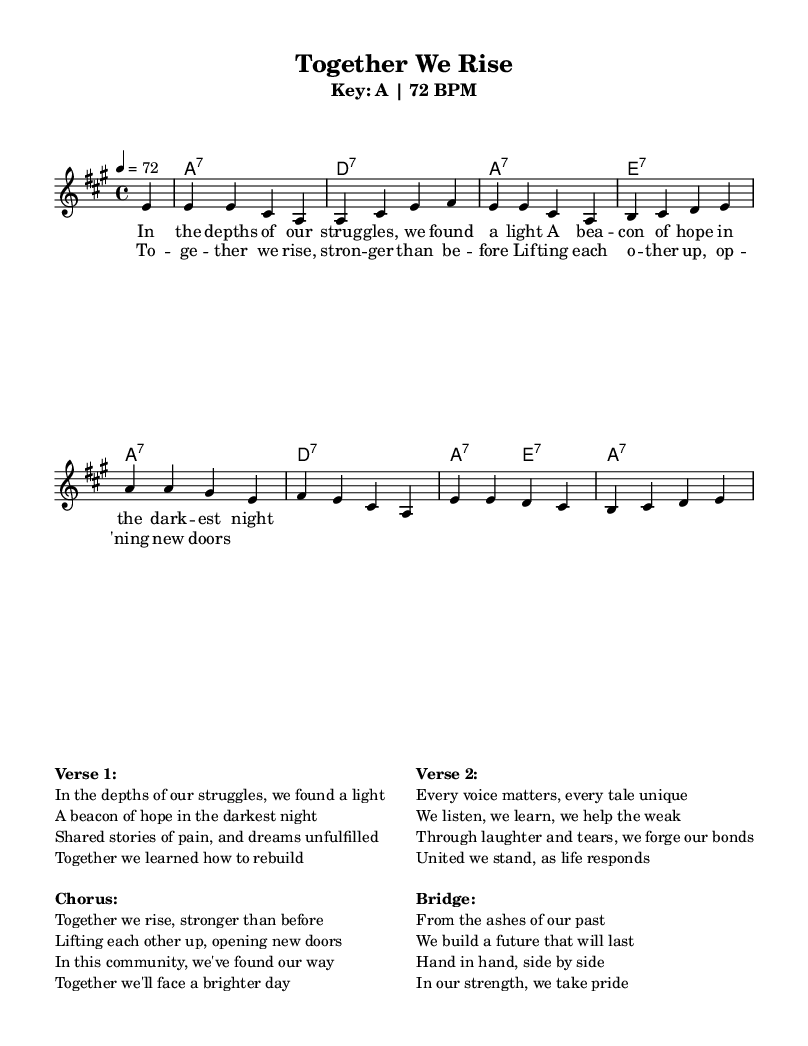What is the key signature of this music? The key signature is indicated by the placement of sharps or flats at the beginning of the staff. In this case, there are three sharps (F#, C#, and G#) marked in the key signature section, which identifies the key as A major.
Answer: A major What is the time signature of this music? The time signature is displayed right after the key signature, indicated in the sheet music as a fraction. Here, it is marked as 4/4, which denotes that there are four beats in each measure.
Answer: 4/4 What is the tempo of the piece? The tempo is typically noted at the beginning of the score, indicating how fast the piece should be played. In this sheet music, it is specified as 72 beats per minute.
Answer: 72 BPM How many verses are included in the song? The lyrics section shows the verses clearly labeled. Here, it shows that there are two verses before the chorus. Counting the labeled sections reveals that there are two distinct verses in the lyrics.
Answer: Two What is the primary theme expressed in the lyrics? To determine the theme, one can look at the content of the lyrics presented in the score. The lyrics discuss community strength, support, and resilience, focusing on uplifting one another. This indicates the core theme is about unity and togetherness in tough times.
Answer: Unity What musical form does this song follow? The structure of the sheet music can be identified by looking at the arrangement of verses and the chorus. The pattern of verses followed by a chorus suggests a common structure for blues music, typically reflecting a verse-chorus format.
Answer: Verse-Chorus How does the music reflect traditional blues characteristics? By analyzing the harmonies and melody structure, we find that the song utilizes seventh chords, a common feature in blues music, giving it a soulful sound. The lyrical content focuses on shared experiences and resilience, which are also hallmark themes of the blues genre.
Answer: Seventh chords, shared experiences 